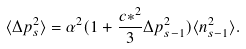<formula> <loc_0><loc_0><loc_500><loc_500>\langle \Delta p _ { s } ^ { 2 } \rangle = \alpha ^ { 2 } ( 1 + \frac { c * ^ { 2 } } { 3 } \Delta p _ { s - 1 } ^ { 2 } ) \langle n _ { s - 1 } ^ { 2 } \rangle .</formula> 